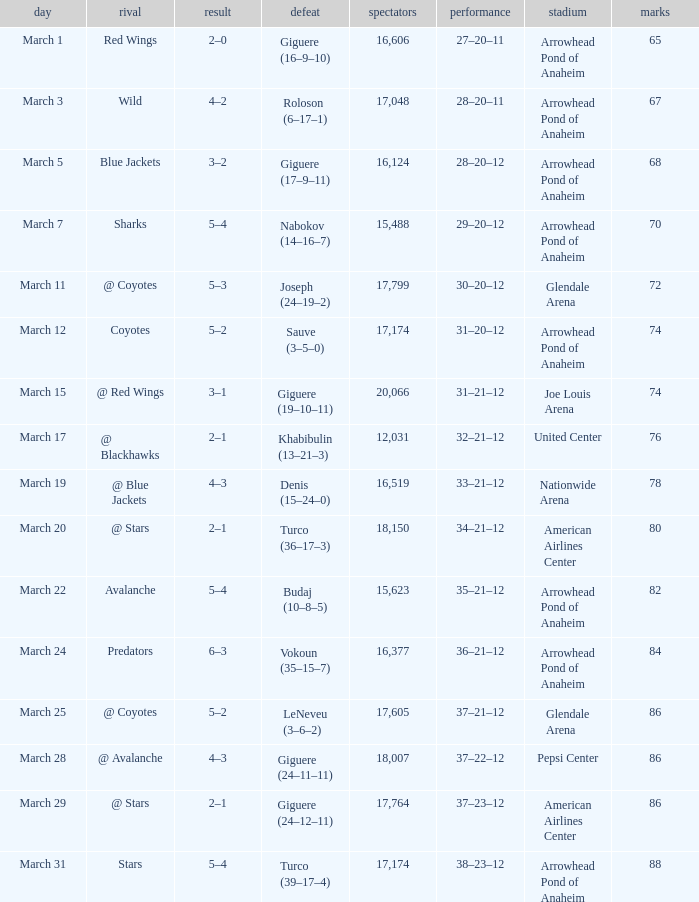What is the Record of the game with an Attendance of more than 16,124 and a Score of 6–3? 36–21–12. 